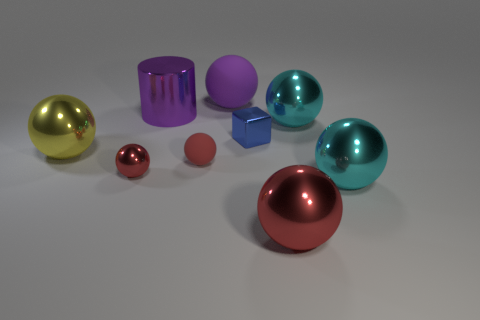Subtract all brown cylinders. How many red spheres are left? 3 Subtract all cyan spheres. How many spheres are left? 5 Subtract 2 balls. How many balls are left? 5 Subtract all yellow shiny spheres. How many spheres are left? 6 Subtract all red balls. Subtract all green cylinders. How many balls are left? 4 Add 1 cyan things. How many objects exist? 10 Subtract all spheres. How many objects are left? 2 Add 9 large yellow metal spheres. How many large yellow metal spheres are left? 10 Add 7 red balls. How many red balls exist? 10 Subtract 0 brown cylinders. How many objects are left? 9 